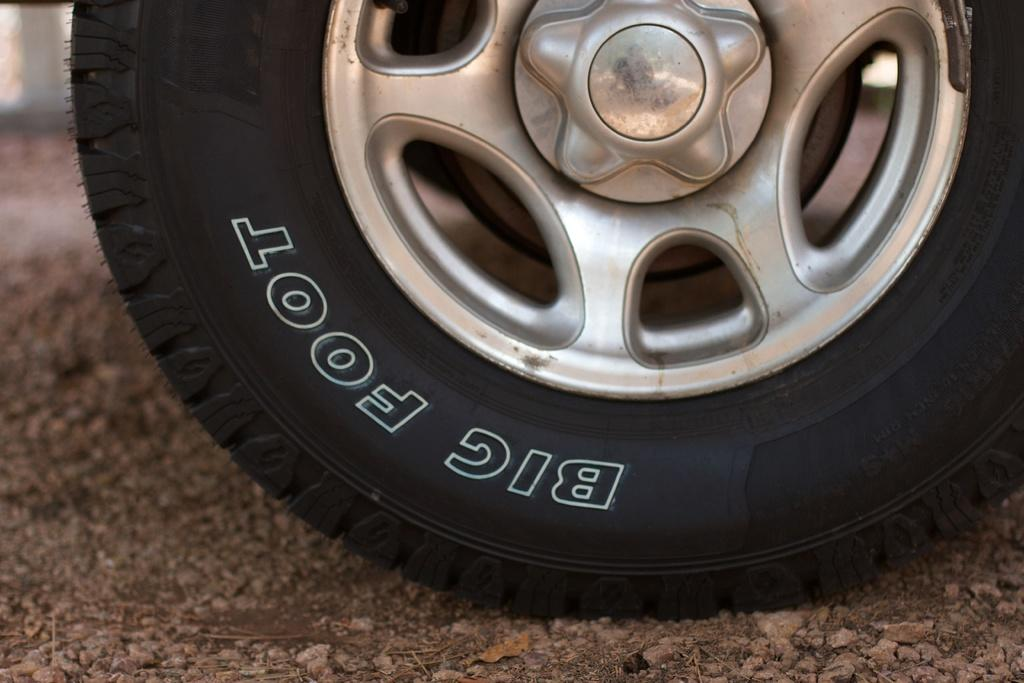What object is the main subject of the image? There is a tire in the image. Are there any markings or text on the tire? Yes, there is text on the tire. What can be seen beneath the tire in the image? The ground is visible in the image. What color is the daughter's sweater in the image? There is no daughter or sweater present in the image; it only features a tire with text on it. 